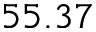<formula> <loc_0><loc_0><loc_500><loc_500>5 5 . 3 7</formula> 